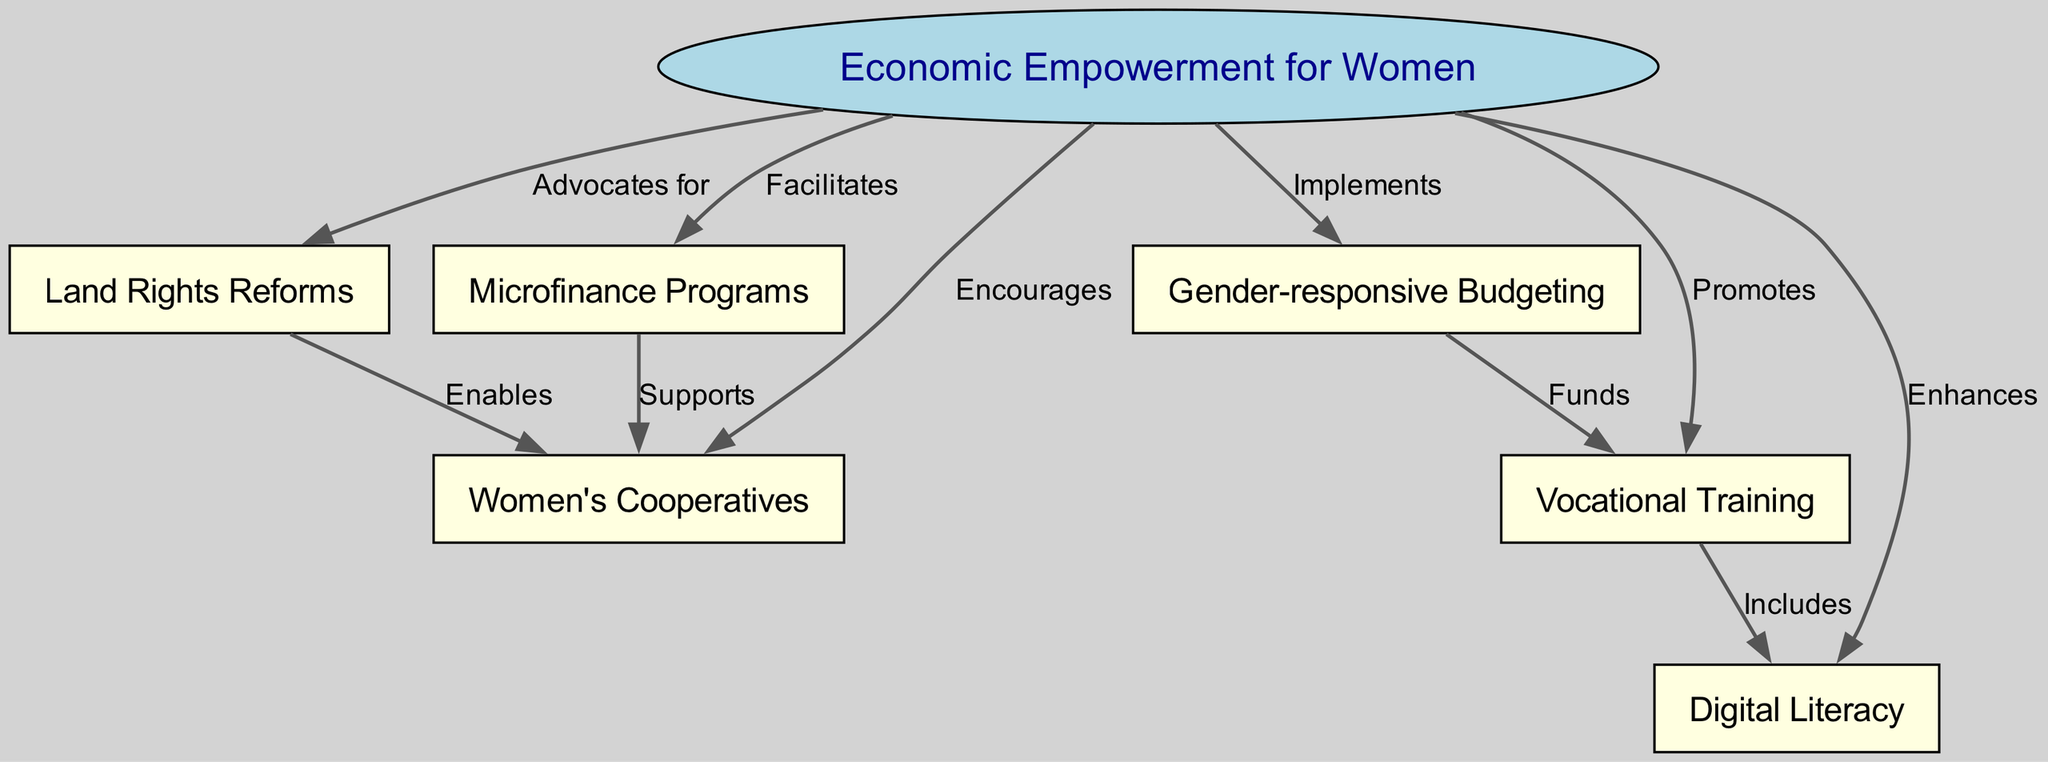What is the central node in the diagram? The central node represents the broad theme of the diagram, which is "Economic Empowerment for Women." This is the main focus and connects to various strategies.
Answer: Economic Empowerment for Women How many nodes are present in the diagram? By counting all unique nodes in the diagram, we see that there are a total of seven nodes representing various strategies related to women's economic empowerment.
Answer: 7 Which strategy is supported by microfinance programs? The edge labeled "Supports" leads from "Microfinance Programs" to "Women's Cooperatives," indicating that microfinance programs are supportive of women's cooperatives.
Answer: Women's Cooperatives What aspect does gender-responsive budgeting fund? The edge labeled "Funds" extends from "Gender-responsive Budgeting" to "Vocational Training," meaning that gender-responsive budgeting specifically provides funding for vocational training initiatives.
Answer: Vocational Training How do vocational training and digital literacy relate? There is an edge labeled "Includes" that indicates vocational training programs encompass or integrate aspects of digital literacy, showing their relationship in empowering women economically.
Answer: Digital Literacy What is advocated for in relation to land rights? The diagram shows an edge labeled "Advocates for" coming from "Economic Empowerment for Women" to "Land Rights Reforms," indicating that economic empowerment stresses the importance of advocating for land rights reforms.
Answer: Land Rights Reforms Which strategy enhances women's digital skills? The node "Enhances" indicates that "Digital Literacy" is specifically enhanced by strategies aimed at "Economic Empowerment for Women," emphasizing its role in improving women's digital capabilities.
Answer: Digital Literacy What promotes vocational training initiatives? There is a direct edge labeled "Promotes" from "Economic Empowerment for Women" to "Vocational Training," indicating that economic empowerment initiatives play a significant role in promoting vocational training.
Answer: Vocational Training 